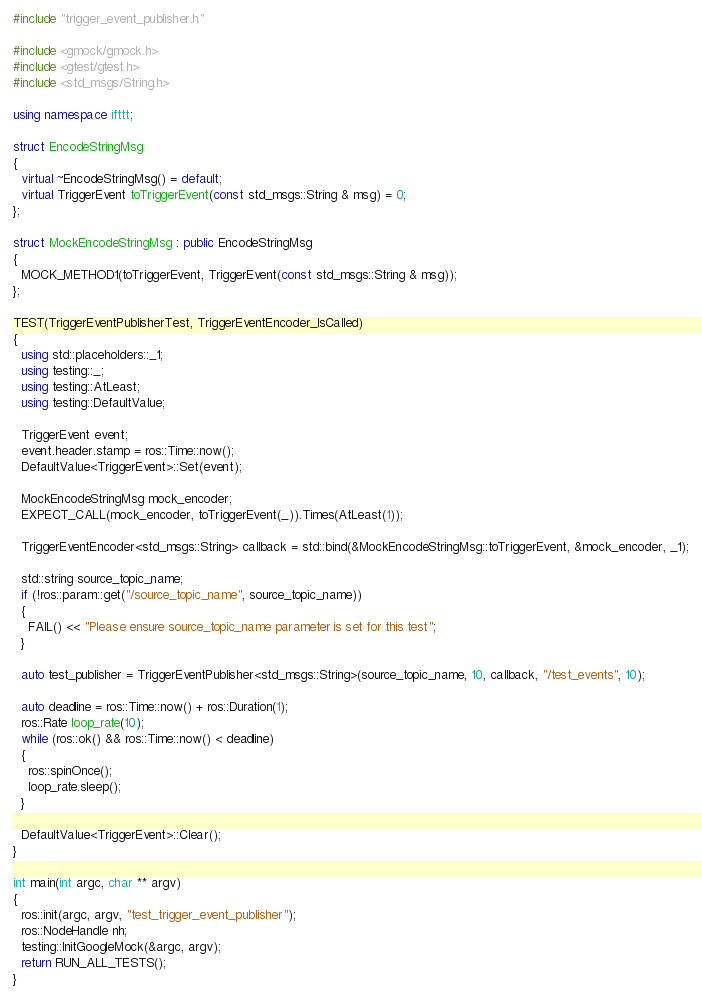<code> <loc_0><loc_0><loc_500><loc_500><_C++_>#include "trigger_event_publisher.h"

#include <gmock/gmock.h>
#include <gtest/gtest.h>
#include <std_msgs/String.h>

using namespace ifttt;

struct EncodeStringMsg
{
  virtual ~EncodeStringMsg() = default;
  virtual TriggerEvent toTriggerEvent(const std_msgs::String & msg) = 0;
};

struct MockEncodeStringMsg : public EncodeStringMsg
{
  MOCK_METHOD1(toTriggerEvent, TriggerEvent(const std_msgs::String & msg));
};

TEST(TriggerEventPublisherTest, TriggerEventEncoder_IsCalled)
{
  using std::placeholders::_1;
  using testing::_;
  using testing::AtLeast;
  using testing::DefaultValue;

  TriggerEvent event;
  event.header.stamp = ros::Time::now();
  DefaultValue<TriggerEvent>::Set(event);

  MockEncodeStringMsg mock_encoder;
  EXPECT_CALL(mock_encoder, toTriggerEvent(_)).Times(AtLeast(1));

  TriggerEventEncoder<std_msgs::String> callback = std::bind(&MockEncodeStringMsg::toTriggerEvent, &mock_encoder, _1);

  std::string source_topic_name;
  if (!ros::param::get("/source_topic_name", source_topic_name))
  {
    FAIL() << "Please ensure source_topic_name parameter is set for this test";
  }

  auto test_publisher = TriggerEventPublisher<std_msgs::String>(source_topic_name, 10, callback, "/test_events", 10);

  auto deadline = ros::Time::now() + ros::Duration(1);
  ros::Rate loop_rate(10);
  while (ros::ok() && ros::Time::now() < deadline)
  {
    ros::spinOnce();
    loop_rate.sleep();
  }

  DefaultValue<TriggerEvent>::Clear();
}

int main(int argc, char ** argv)
{
  ros::init(argc, argv, "test_trigger_event_publisher");
  ros::NodeHandle nh;
  testing::InitGoogleMock(&argc, argv);
  return RUN_ALL_TESTS();
}</code> 